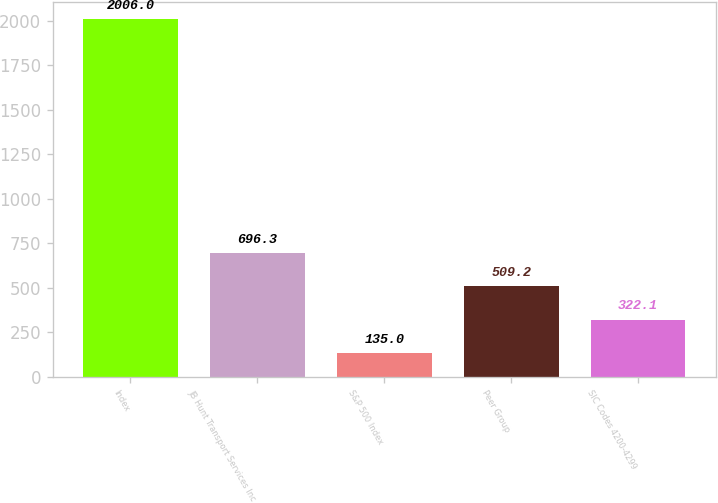Convert chart. <chart><loc_0><loc_0><loc_500><loc_500><bar_chart><fcel>Index<fcel>JB Hunt Transport Services Inc<fcel>S&P 500 Index<fcel>Peer Group<fcel>SIC Codes 4200-4299<nl><fcel>2006<fcel>696.3<fcel>135<fcel>509.2<fcel>322.1<nl></chart> 